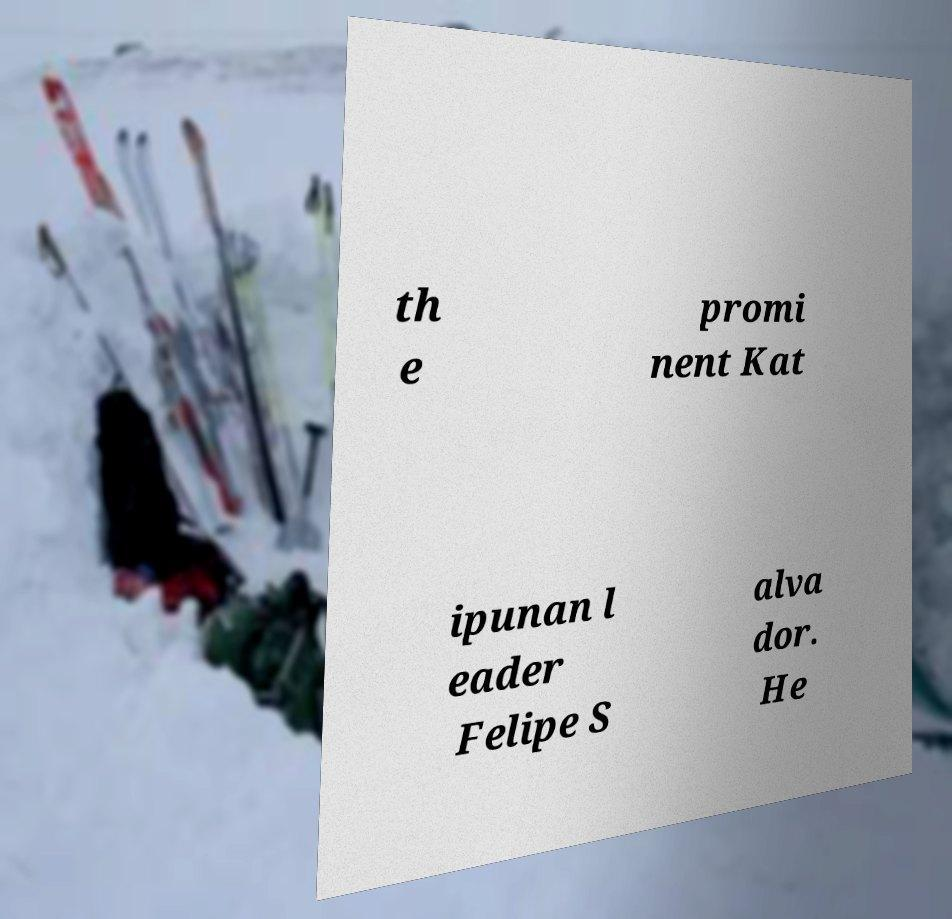There's text embedded in this image that I need extracted. Can you transcribe it verbatim? th e promi nent Kat ipunan l eader Felipe S alva dor. He 